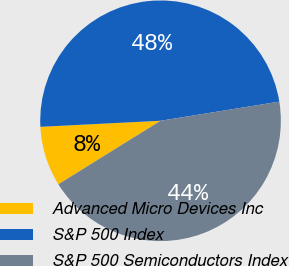Convert chart. <chart><loc_0><loc_0><loc_500><loc_500><pie_chart><fcel>Advanced Micro Devices Inc<fcel>S&P 500 Index<fcel>S&P 500 Semiconductors Index<nl><fcel>8.05%<fcel>48.26%<fcel>43.69%<nl></chart> 